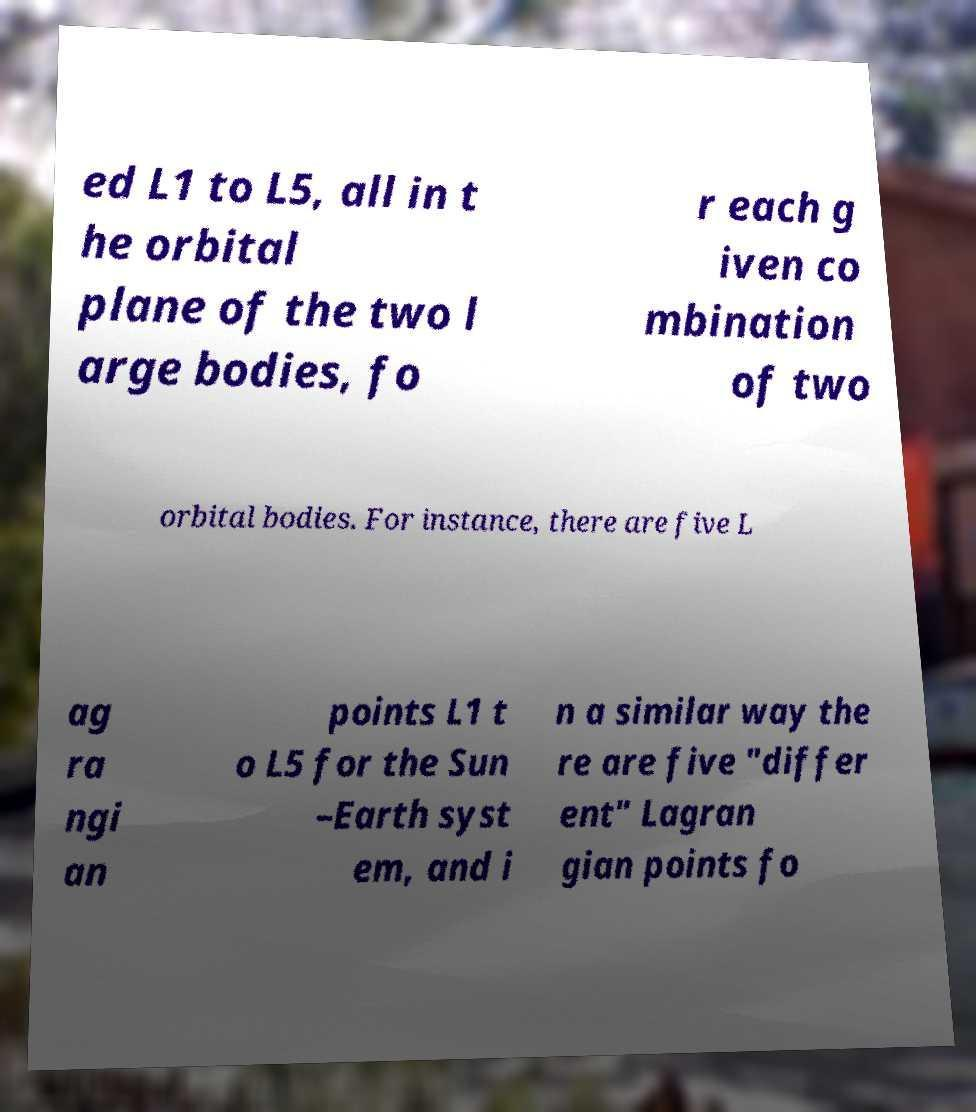Can you accurately transcribe the text from the provided image for me? ed L1 to L5, all in t he orbital plane of the two l arge bodies, fo r each g iven co mbination of two orbital bodies. For instance, there are five L ag ra ngi an points L1 t o L5 for the Sun –Earth syst em, and i n a similar way the re are five "differ ent" Lagran gian points fo 